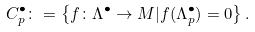Convert formula to latex. <formula><loc_0><loc_0><loc_500><loc_500>C ^ { \bullet } _ { p } \colon = \left \{ f \colon \Lambda ^ { \bullet } \to M | f ( \Lambda ^ { \bullet } _ { p } ) = 0 \right \} .</formula> 